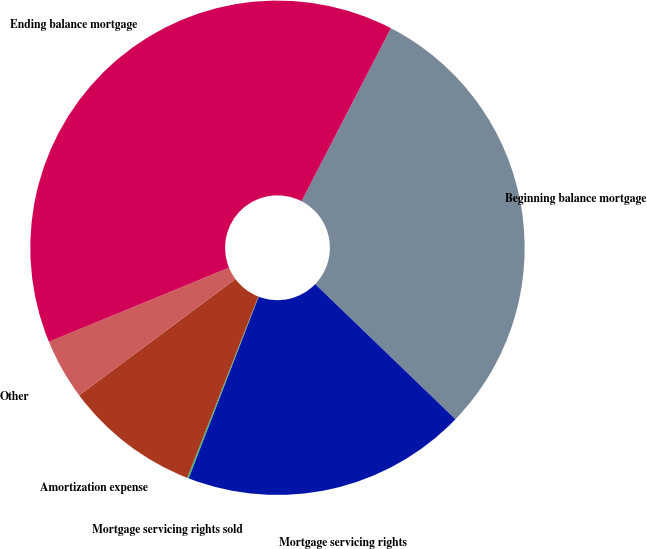Convert chart to OTSL. <chart><loc_0><loc_0><loc_500><loc_500><pie_chart><fcel>Beginning balance mortgage<fcel>Mortgage servicing rights<fcel>Mortgage servicing rights sold<fcel>Amortization expense<fcel>Other<fcel>Ending balance mortgage<nl><fcel>29.62%<fcel>18.65%<fcel>0.1%<fcel>8.87%<fcel>3.97%<fcel>38.8%<nl></chart> 